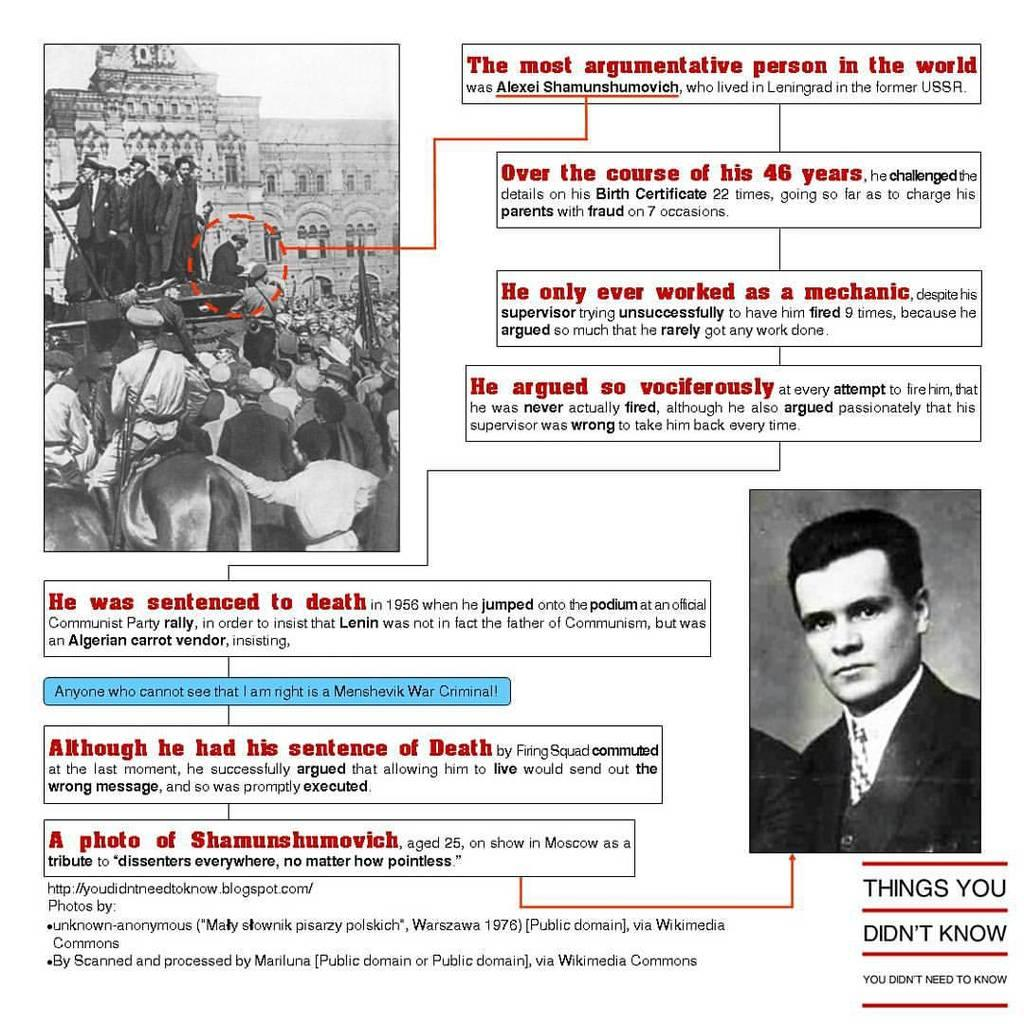What type of images are present in the picture? There are two black and white images in the picture. What is happening in the first image? The first image shows a group of people standing. What is depicted in the second image? The second image shows a person. Is there any text visible on the images? Yes, there is some text visible on the image. How does the person in the second image process the note they are holding? There is no note present in the image, and the person in the second image is not depicted holding anything. 